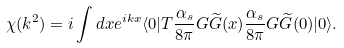Convert formula to latex. <formula><loc_0><loc_0><loc_500><loc_500>\chi ( k ^ { 2 } ) = i \int d x e ^ { i k x } \langle 0 | T \frac { \alpha _ { s } } { 8 \pi } G \widetilde { G } ( x ) \frac { \alpha _ { s } } { 8 \pi } G \widetilde { G } ( 0 ) | 0 \rangle .</formula> 